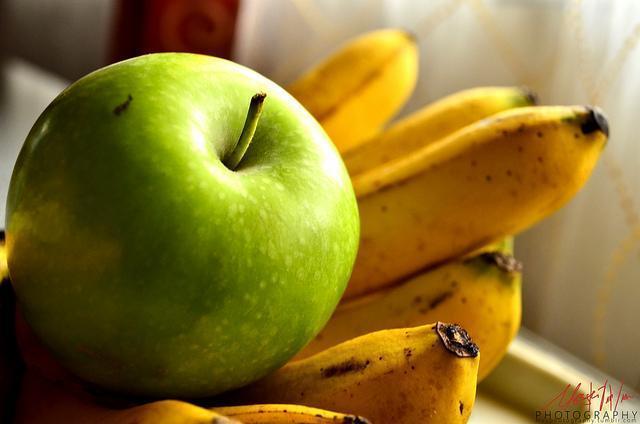Is this affirmation: "The apple is on top of the banana." correct?
Answer yes or no. Yes. Does the image validate the caption "The apple is touching the banana."?
Answer yes or no. Yes. 